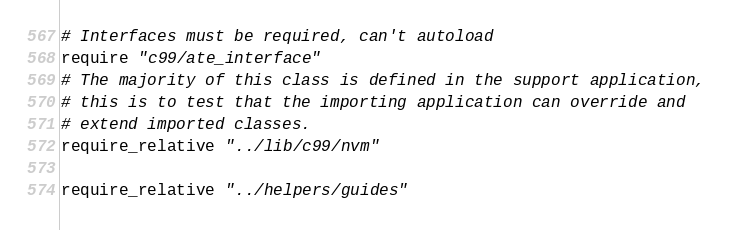Convert code to text. <code><loc_0><loc_0><loc_500><loc_500><_Ruby_># Interfaces must be required, can't autoload
require "c99/ate_interface"
# The majority of this class is defined in the support application,
# this is to test that the importing application can override and
# extend imported classes.
require_relative "../lib/c99/nvm"

require_relative "../helpers/guides"
</code> 